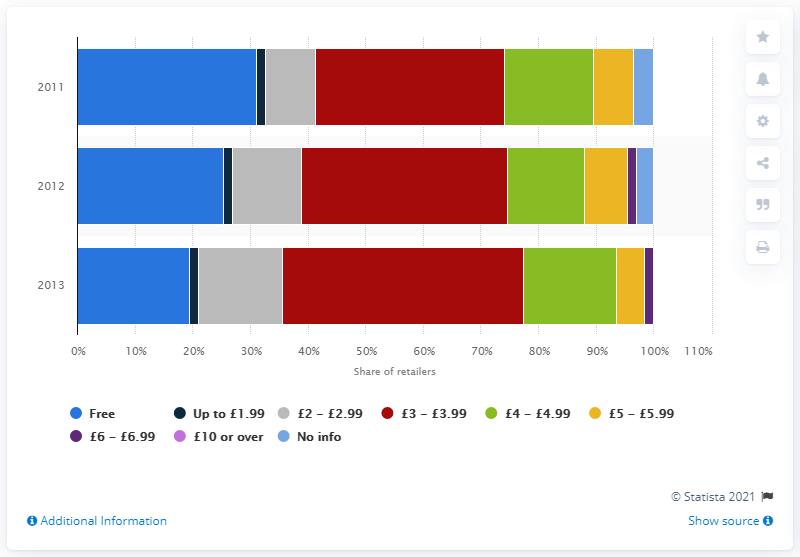Mention a couple of crucial points in this snapshot. In 2013, a significant percentage of online retailers offered standard delivery for a price range of 3 to 3.99 British pounds. Specifically, approximately 41.9% of online retailers offered this type of delivery option. 